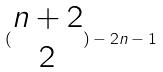Convert formula to latex. <formula><loc_0><loc_0><loc_500><loc_500>( \begin{matrix} n + 2 \\ 2 \end{matrix} ) - 2 n - 1</formula> 